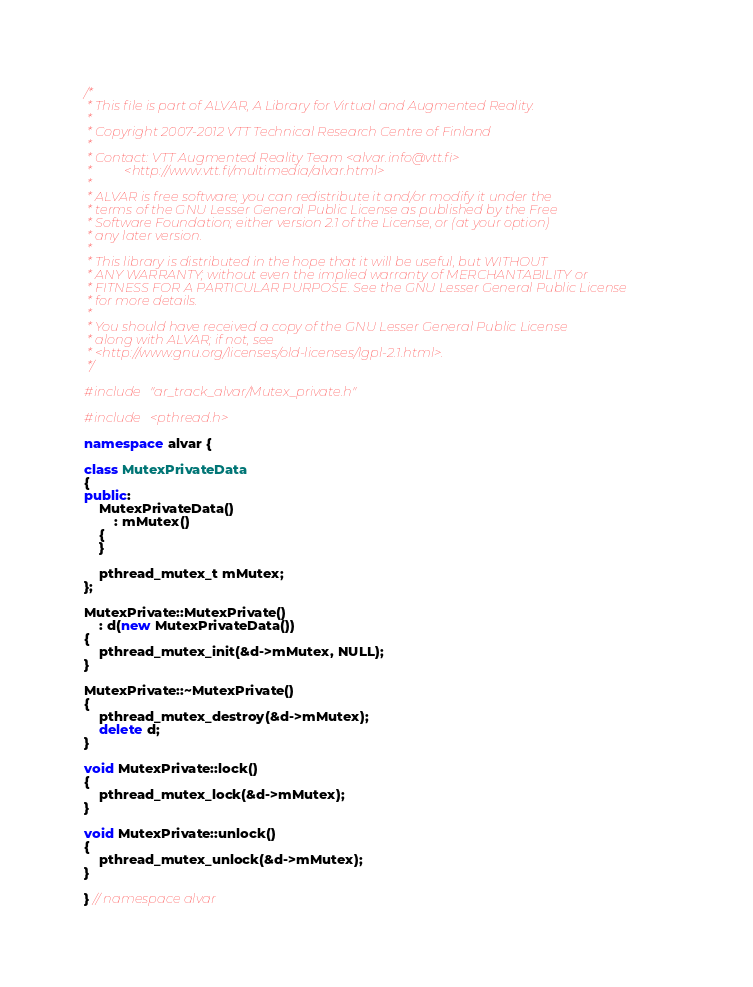Convert code to text. <code><loc_0><loc_0><loc_500><loc_500><_C++_>/*
 * This file is part of ALVAR, A Library for Virtual and Augmented Reality.
 *
 * Copyright 2007-2012 VTT Technical Research Centre of Finland
 *
 * Contact: VTT Augmented Reality Team <alvar.info@vtt.fi>
 *          <http://www.vtt.fi/multimedia/alvar.html>
 *
 * ALVAR is free software; you can redistribute it and/or modify it under the
 * terms of the GNU Lesser General Public License as published by the Free
 * Software Foundation; either version 2.1 of the License, or (at your option)
 * any later version.
 *
 * This library is distributed in the hope that it will be useful, but WITHOUT
 * ANY WARRANTY; without even the implied warranty of MERCHANTABILITY or
 * FITNESS FOR A PARTICULAR PURPOSE. See the GNU Lesser General Public License
 * for more details.
 *
 * You should have received a copy of the GNU Lesser General Public License
 * along with ALVAR; if not, see
 * <http://www.gnu.org/licenses/old-licenses/lgpl-2.1.html>.
 */

#include "ar_track_alvar/Mutex_private.h"

#include <pthread.h>

namespace alvar {

class MutexPrivateData
{
public:
    MutexPrivateData()
        : mMutex()
    {
    }

    pthread_mutex_t mMutex;
};

MutexPrivate::MutexPrivate()
    : d(new MutexPrivateData())
{
    pthread_mutex_init(&d->mMutex, NULL);
}

MutexPrivate::~MutexPrivate()
{
    pthread_mutex_destroy(&d->mMutex);
    delete d;
}

void MutexPrivate::lock()
{
    pthread_mutex_lock(&d->mMutex);
}

void MutexPrivate::unlock()
{
    pthread_mutex_unlock(&d->mMutex);
}

} // namespace alvar
</code> 